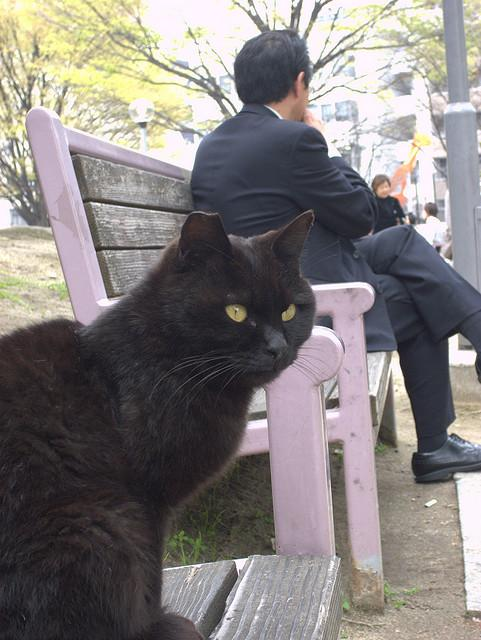What animal is on the bench?

Choices:
A) dog
B) black cat
C) orange cat
D) badger black cat 